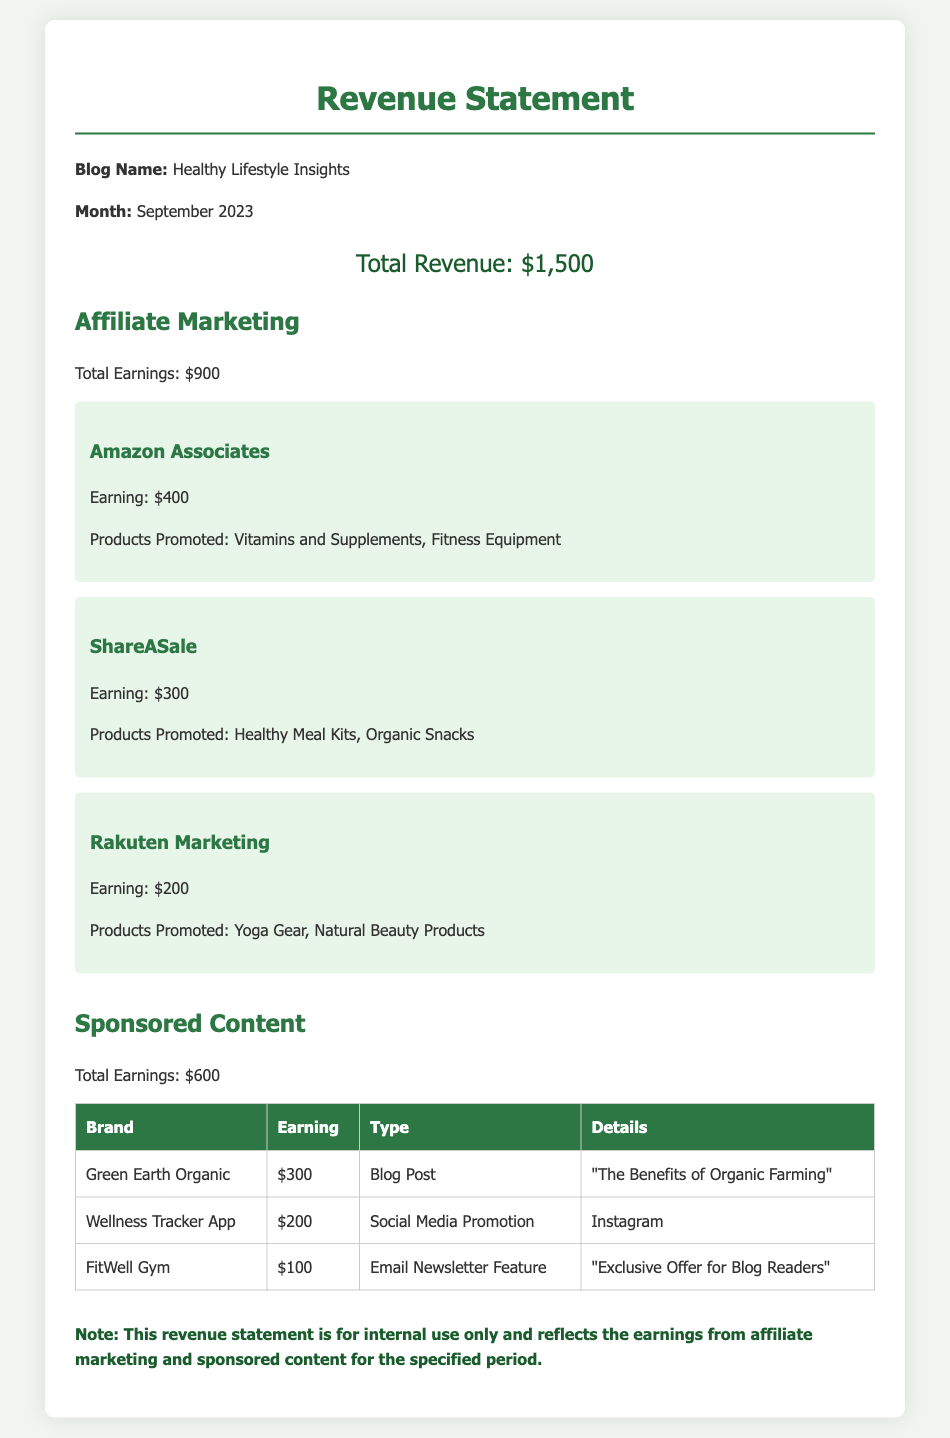what is the total revenue? The total revenue is given as the overall earnings from both affiliate marketing and sponsored content, which is $1,500.
Answer: $1,500 how much did affiliate marketing earn? The document specifies the total earnings from affiliate marketing, which amounts to $900.
Answer: $900 what is the earning from Amazon Associates? The earning from Amazon Associates is detailed in the subsection, which amounts to $400.
Answer: $400 how much did Green Earth Organic pay for sponsored content? The document lists the payment from Green Earth Organic in the sponsored content section, which is $300.
Answer: $300 how many brands are listed under sponsored content? The table in the document lists three brands associated with sponsored content.
Answer: 3 which product category earned the most in affiliate marketing? The highest earning in affiliate marketing comes from Amazon Associates, which promoted Vitamins and Supplements and Fitness Equipment.
Answer: Amazon Associates what type of content did FitWell Gym sponsor? The document specifies that FitWell Gym sponsored an Email Newsletter Feature.
Answer: Email Newsletter Feature what is the total earning from Rakuten Marketing? The document states that the earning from Rakuten Marketing was $200.
Answer: $200 which brand had the highest earning in the sponsored content section? The brand with the highest earning listed in the table is Green Earth Organic, earning $300.
Answer: Green Earth Organic 